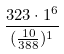<formula> <loc_0><loc_0><loc_500><loc_500>\frac { 3 2 3 \cdot 1 ^ { 6 } } { ( \frac { 1 0 } { 3 8 8 } ) ^ { 1 } }</formula> 